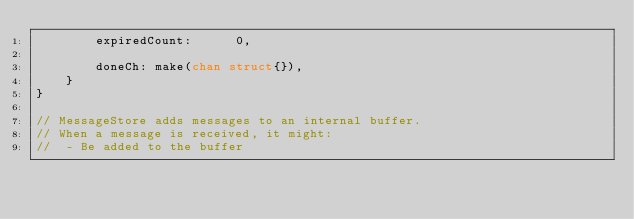<code> <loc_0><loc_0><loc_500><loc_500><_Go_>		expiredCount:      0,

		doneCh: make(chan struct{}),
	}
}

// MessageStore adds messages to an internal buffer.
// When a message is received, it might:
// 	- Be added to the buffer</code> 